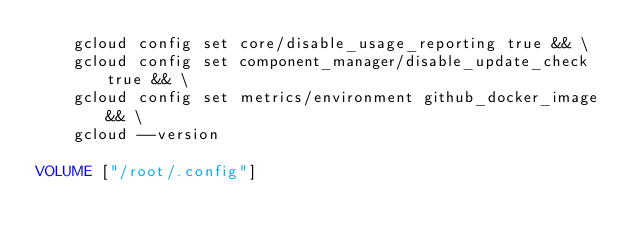<code> <loc_0><loc_0><loc_500><loc_500><_Dockerfile_>    gcloud config set core/disable_usage_reporting true && \
    gcloud config set component_manager/disable_update_check true && \
    gcloud config set metrics/environment github_docker_image && \
    gcloud --version

VOLUME ["/root/.config"]
</code> 